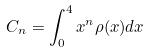Convert formula to latex. <formula><loc_0><loc_0><loc_500><loc_500>C _ { n } = \int _ { 0 } ^ { 4 } x ^ { n } \rho ( x ) d x</formula> 